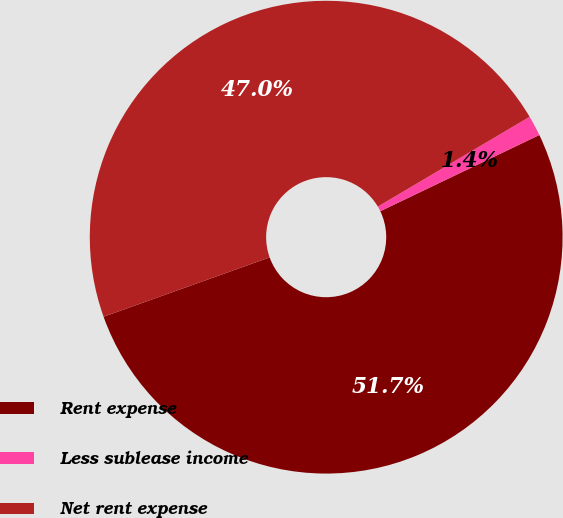Convert chart to OTSL. <chart><loc_0><loc_0><loc_500><loc_500><pie_chart><fcel>Rent expense<fcel>Less sublease income<fcel>Net rent expense<nl><fcel>51.65%<fcel>1.39%<fcel>46.96%<nl></chart> 